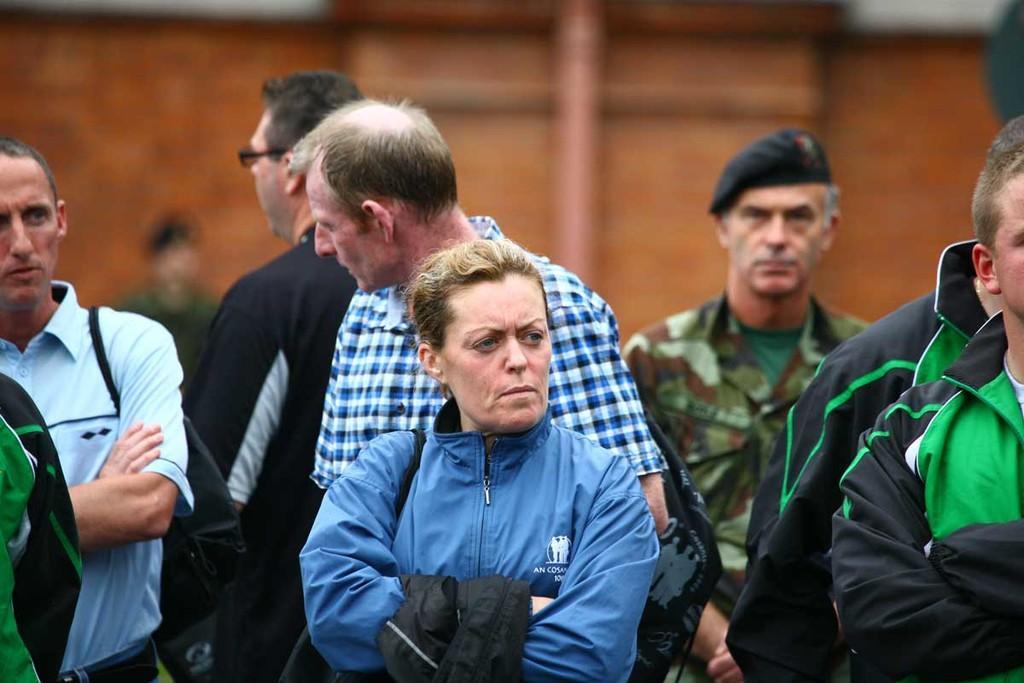Could you give a brief overview of what you see in this image? In this image we can see many persons on the ground. In the background there is building. 